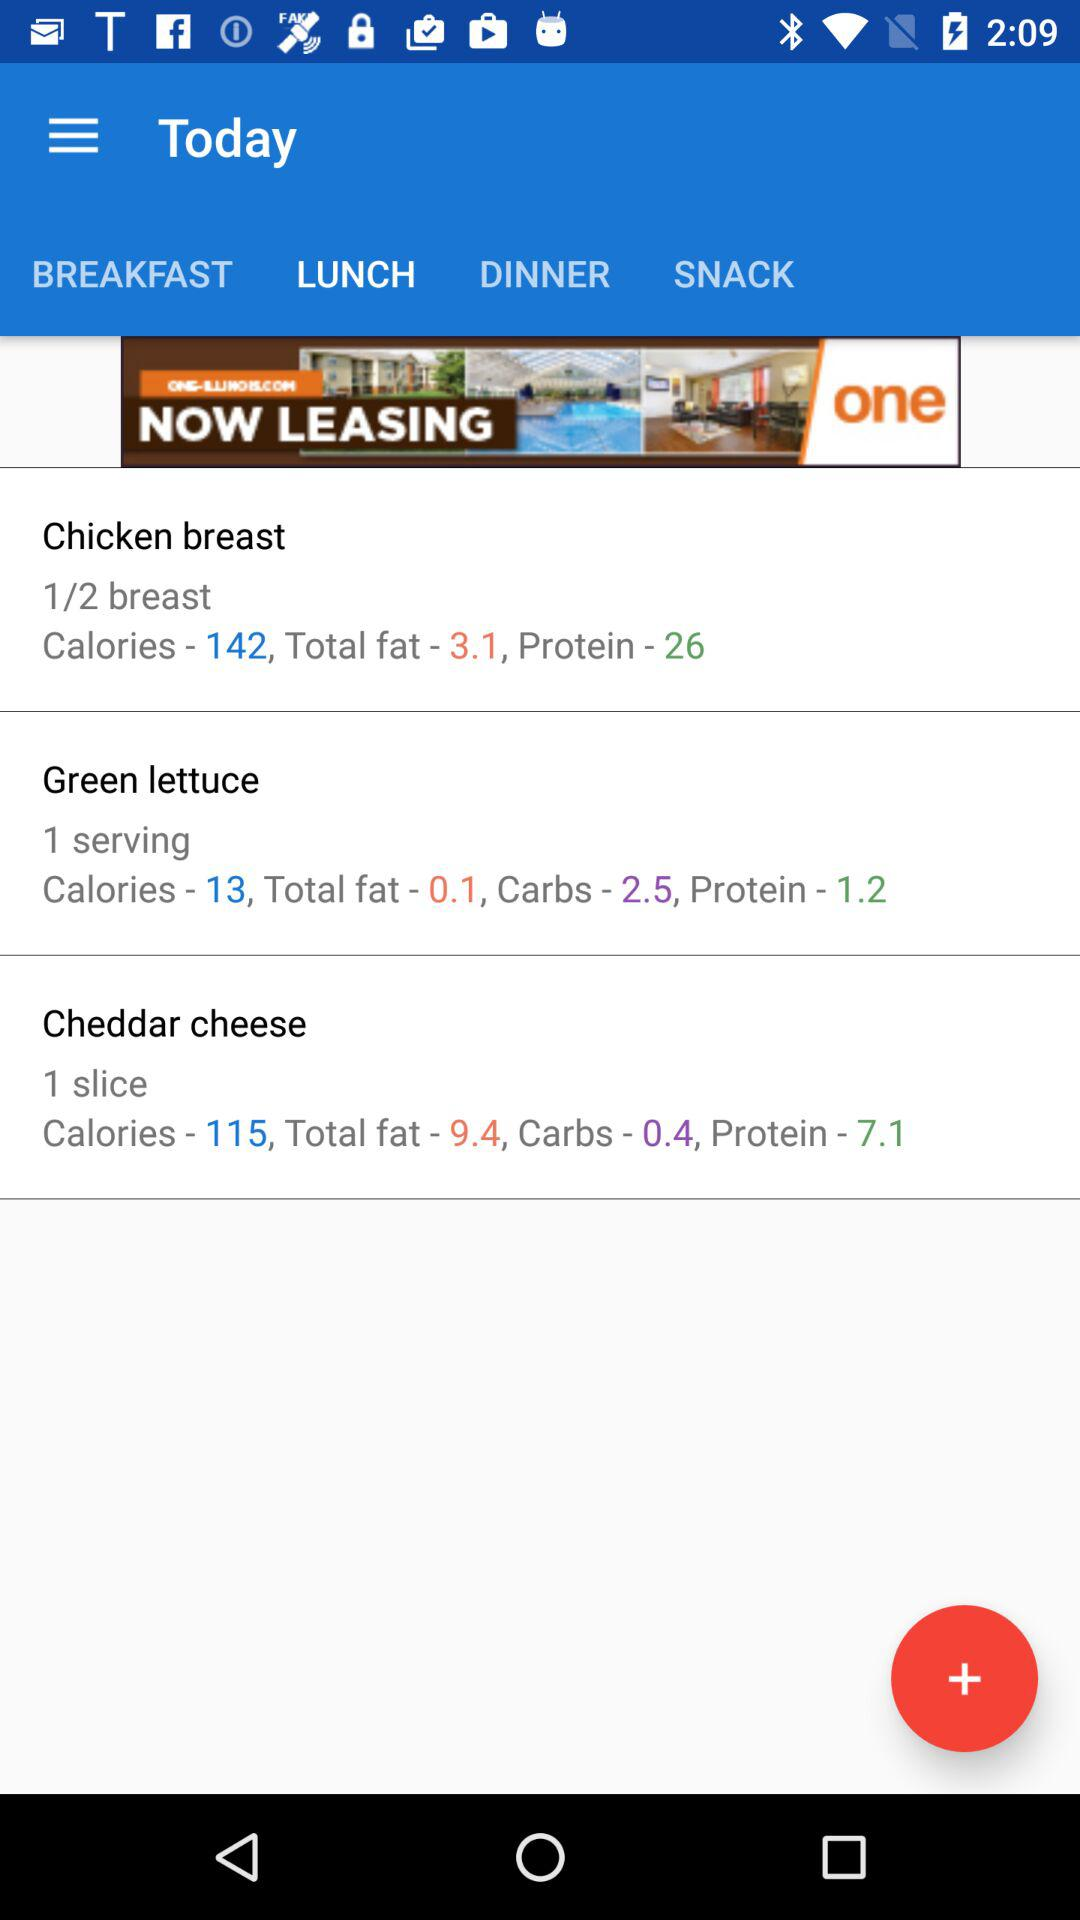How many slices of "Cheddar cheese" are there? There is 1 slice of "Cheddar cheese". 